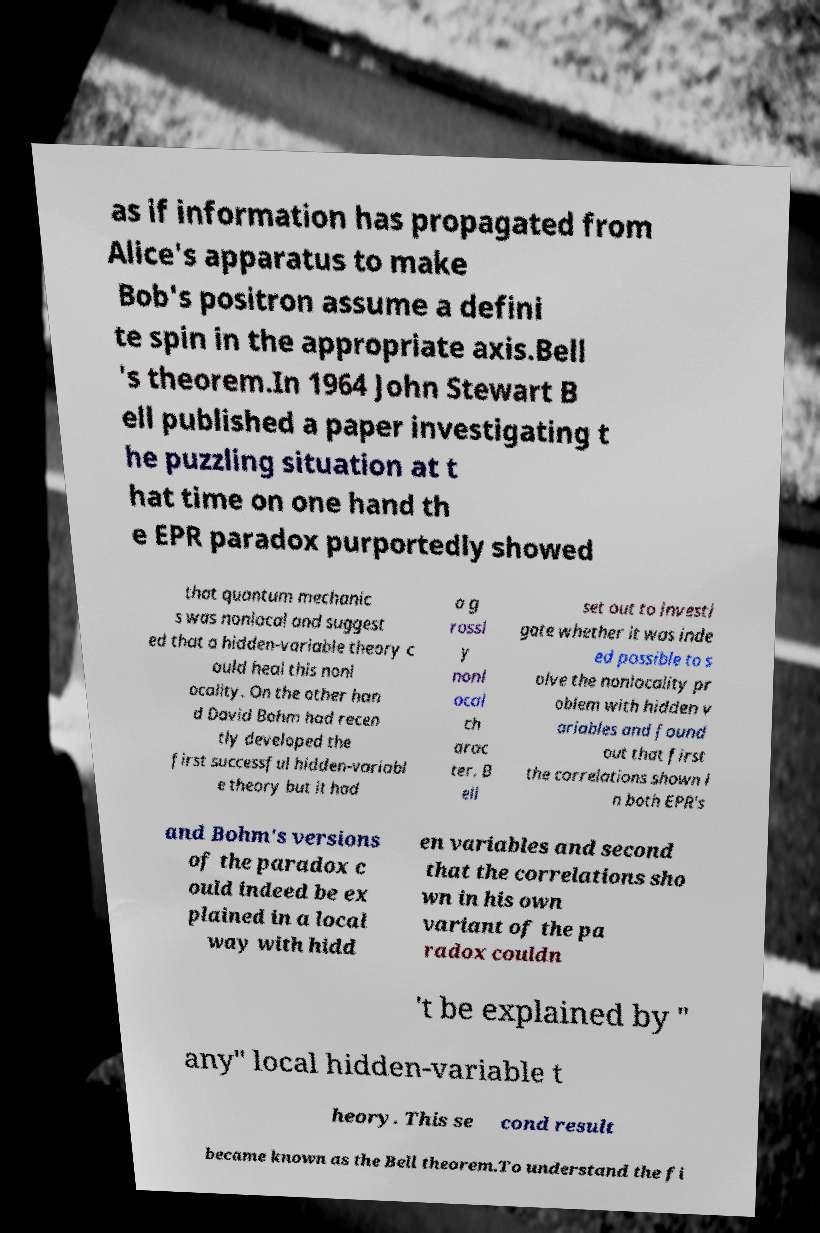What messages or text are displayed in this image? I need them in a readable, typed format. as if information has propagated from Alice's apparatus to make Bob's positron assume a defini te spin in the appropriate axis.Bell 's theorem.In 1964 John Stewart B ell published a paper investigating t he puzzling situation at t hat time on one hand th e EPR paradox purportedly showed that quantum mechanic s was nonlocal and suggest ed that a hidden-variable theory c ould heal this nonl ocality. On the other han d David Bohm had recen tly developed the first successful hidden-variabl e theory but it had a g rossl y nonl ocal ch arac ter. B ell set out to investi gate whether it was inde ed possible to s olve the nonlocality pr oblem with hidden v ariables and found out that first the correlations shown i n both EPR's and Bohm's versions of the paradox c ould indeed be ex plained in a local way with hidd en variables and second that the correlations sho wn in his own variant of the pa radox couldn 't be explained by " any" local hidden-variable t heory. This se cond result became known as the Bell theorem.To understand the fi 